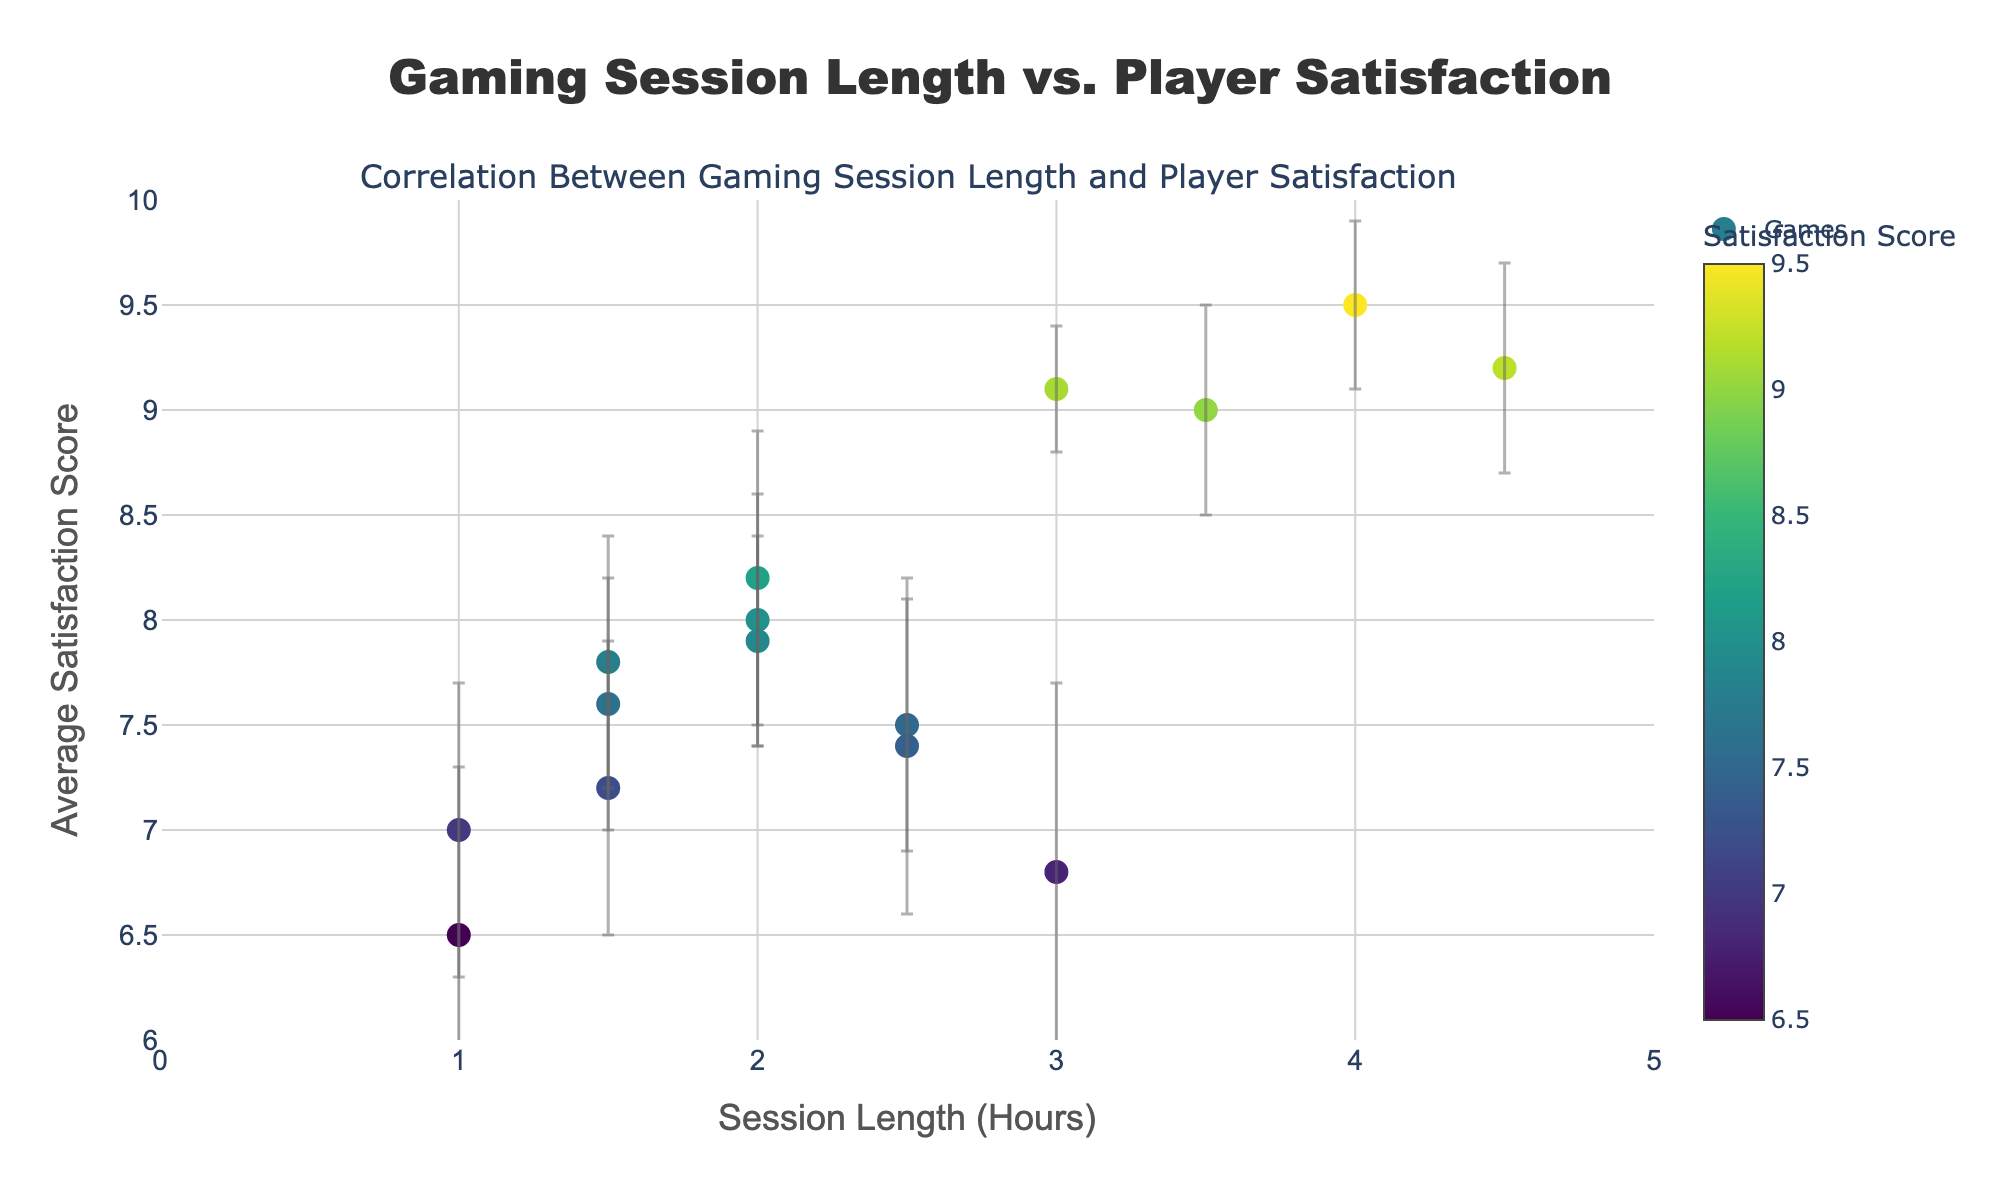What is the main title of the figure? The title is located at the top of the figure and usually summarizes the main message of the plot. Look above the figure to find the title.
Answer: Gaming Session Length vs. Player Satisfaction How many data points are shown in the figure? Count each marker on the scatter plot to determine the number of data points.
Answer: 15 Which game has the highest average satisfaction score, and what is that score? Identify the data point with the highest y-value (average satisfaction score) and look at the hover text or legend for the game title.
Answer: Minecraft, 9.5 What is the session length and satisfaction score for "Cyberpunk 2077"? Locate the data point for "Cyberpunk 2077" by hovering over the points or checking the legend, then write down the x and y values.
Answer: 3.0 hours, 6.8 Which game has the lowest average satisfaction score, and what is it? Identify the data point with the lowest y-value on the plot and look at the hover text or legend for the game title.
Answer: FIFA 22, 6.5 Are there more games with a session length greater than or equal to 3 hours or less than 3 hours? Count the number of data points with x-values greater than or equal to 3 and compare them with those less than 3.
Answer: Less than 3 hours What is the range of session lengths represented in the figure? Determine the minimum and maximum x-values (session lengths) on the x-axis, then calculate the difference between them.
Answer: 1.0 to 4.5 hours Which games have an average satisfaction score within the error range of 7.5 to 8.5? Identify the data points within or crossing the y-values of 7.5 and 8.5, looking at the error bars for exact matches.
Answer: League of Legends, Fortnite, Apex Legends, Valorant What is the average satisfaction score for games with a session length of 2.0 hours? Look at the y-values for data points with an x-value of 2.0 hours and calculate their average. (8.2 + 8.0 + 7.9) / 3 = 8.03
Answer: 8.03 What is the approximate correlation between session length and satisfaction score? Look at the overall trend of the data points, determining whether they generally increase, decrease or stay the same as session length increases.
Answer: Generally positive 